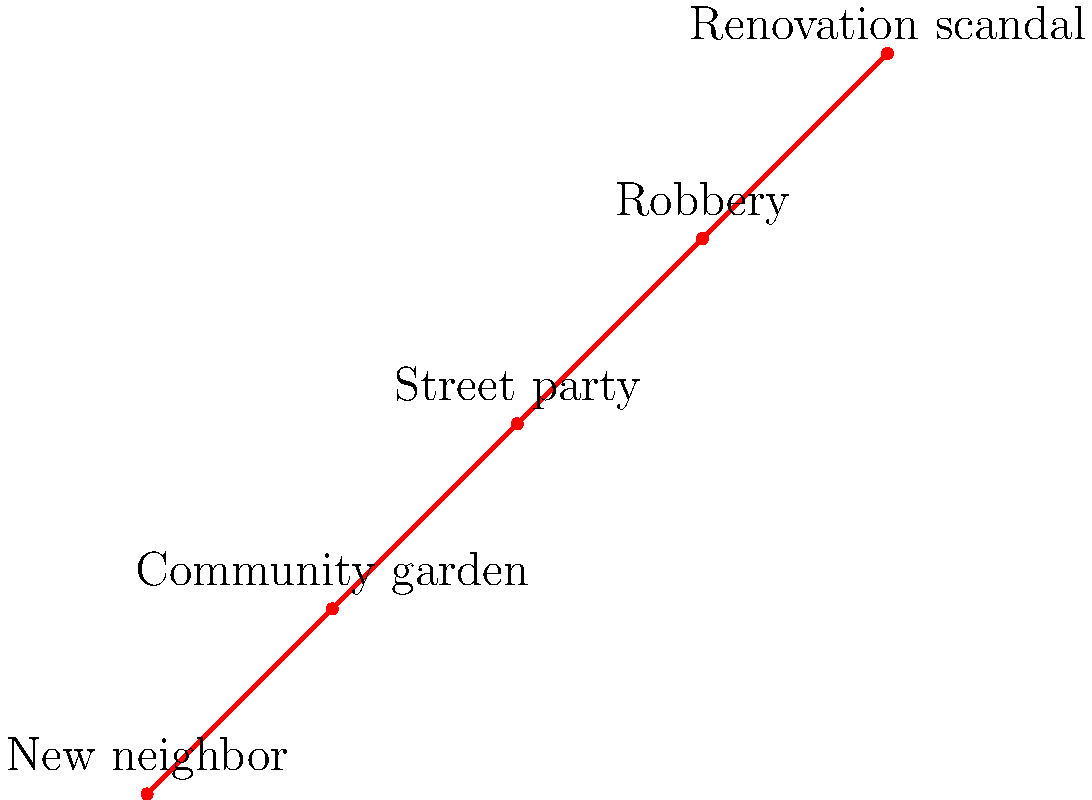Based on the timeline of notable neighborhood events, which incident is likely to have caused the most buzz and discussion among the residents? To determine which event caused the most buzz, we need to consider the nature of each event and its potential impact on the community:

1. 2019: New neighbor - Interesting, but not exceptionally noteworthy.
2. 2020: Community garden - Positive, but likely not controversial.
3. 2021: Street party - Fun, but probably not a long-lasting topic of discussion.
4. 2022: Robbery - Concerning, but might not affect everyone directly.
5. 2023: Renovation scandal - This event stands out as potentially the most controversial and gossip-worthy.

The renovation scandal in 2023 is likely to have caused the most buzz because:
1. It's the most recent event, making it fresh in people's minds.
2. The word "scandal" implies something secretive or improper occurred.
3. Renovations often involve significant amounts of money, potentially raising questions about financial impropriety.
4. It likely affects multiple community members, either directly or indirectly.
5. Scandals typically involve complex stories with multiple parties, providing ample material for gossip and speculation.

Therefore, the renovation scandal of 2023 is the most likely event to have caused significant discussion among the residents.
Answer: Renovation scandal (2023) 